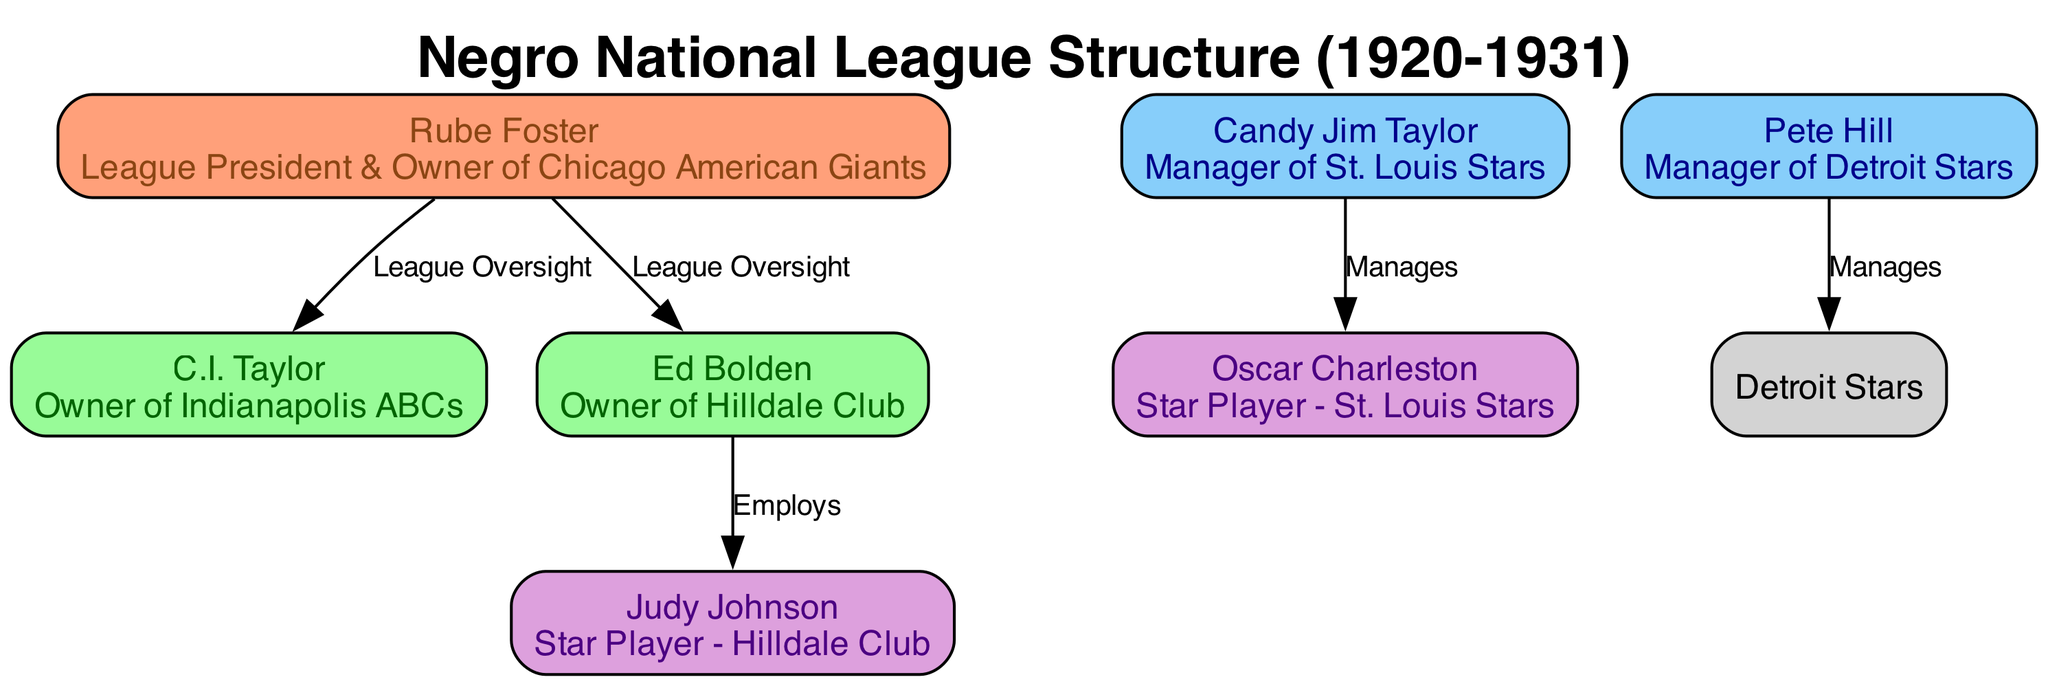What is the name of the League President? The diagram identifies Rube Foster as the League President at the top. He is labeled clearly with his role, indicating his significance in the organizational structure.
Answer: Rube Foster Who manages the St. Louis Stars? According to the diagram, Candy Jim Taylor is linked to Oscar Charleston with the label "Manages," indicating that he is the manager of the St. Louis Stars.
Answer: Candy Jim Taylor How many owners are listed in the diagram? The diagram contains three nodes classified as owners: Rube Foster, C.I. Taylor, and Ed Bolden. Counting these nodes gives the total number of owners.
Answer: 3 What role does Ed Bolden have in relation to Judy Johnson? The diagram shows an edge labeled "Employs" from Ed Bolden to Judy Johnson, which indicates that Ed Bolden employs Judy Johnson within the Hilldale Club organization.
Answer: Employs Which team is Oscar Charleston associated with? The diagram shows that Oscar Charleston is a star player specifically linked to the St. Louis Stars, which is indicated next to his name.
Answer: St. Louis Stars What is the relationship between Rube Foster and C.I. Taylor? The diagram highlights an edge labeled "League Oversight" connecting Rube Foster and C.I. Taylor, which signifies that Rube Foster oversees C.I. Taylor's activities as an owner.
Answer: League Oversight Who is the owner of the Indianapolis ABCs? The diagram specifies that C.I. Taylor is labeled as the owner of the Indianapolis ABCs, providing clear identification of his role.
Answer: C.I. Taylor What color represents team managers in the diagram? The diagram's style indicates that nodes representing managers, like Candy Jim Taylor and Pete Hill, are filled with a light blue color (87CEFA). The diagram’s legend shows the color for managers distinctly.
Answer: Light blue What label is used for the connection between Pete Hill and the Detroit Stars? The diagram connects Pete Hill to the Detroit Stars with the label "Manages," which identifies his role regarding the team clearly.
Answer: Manages 